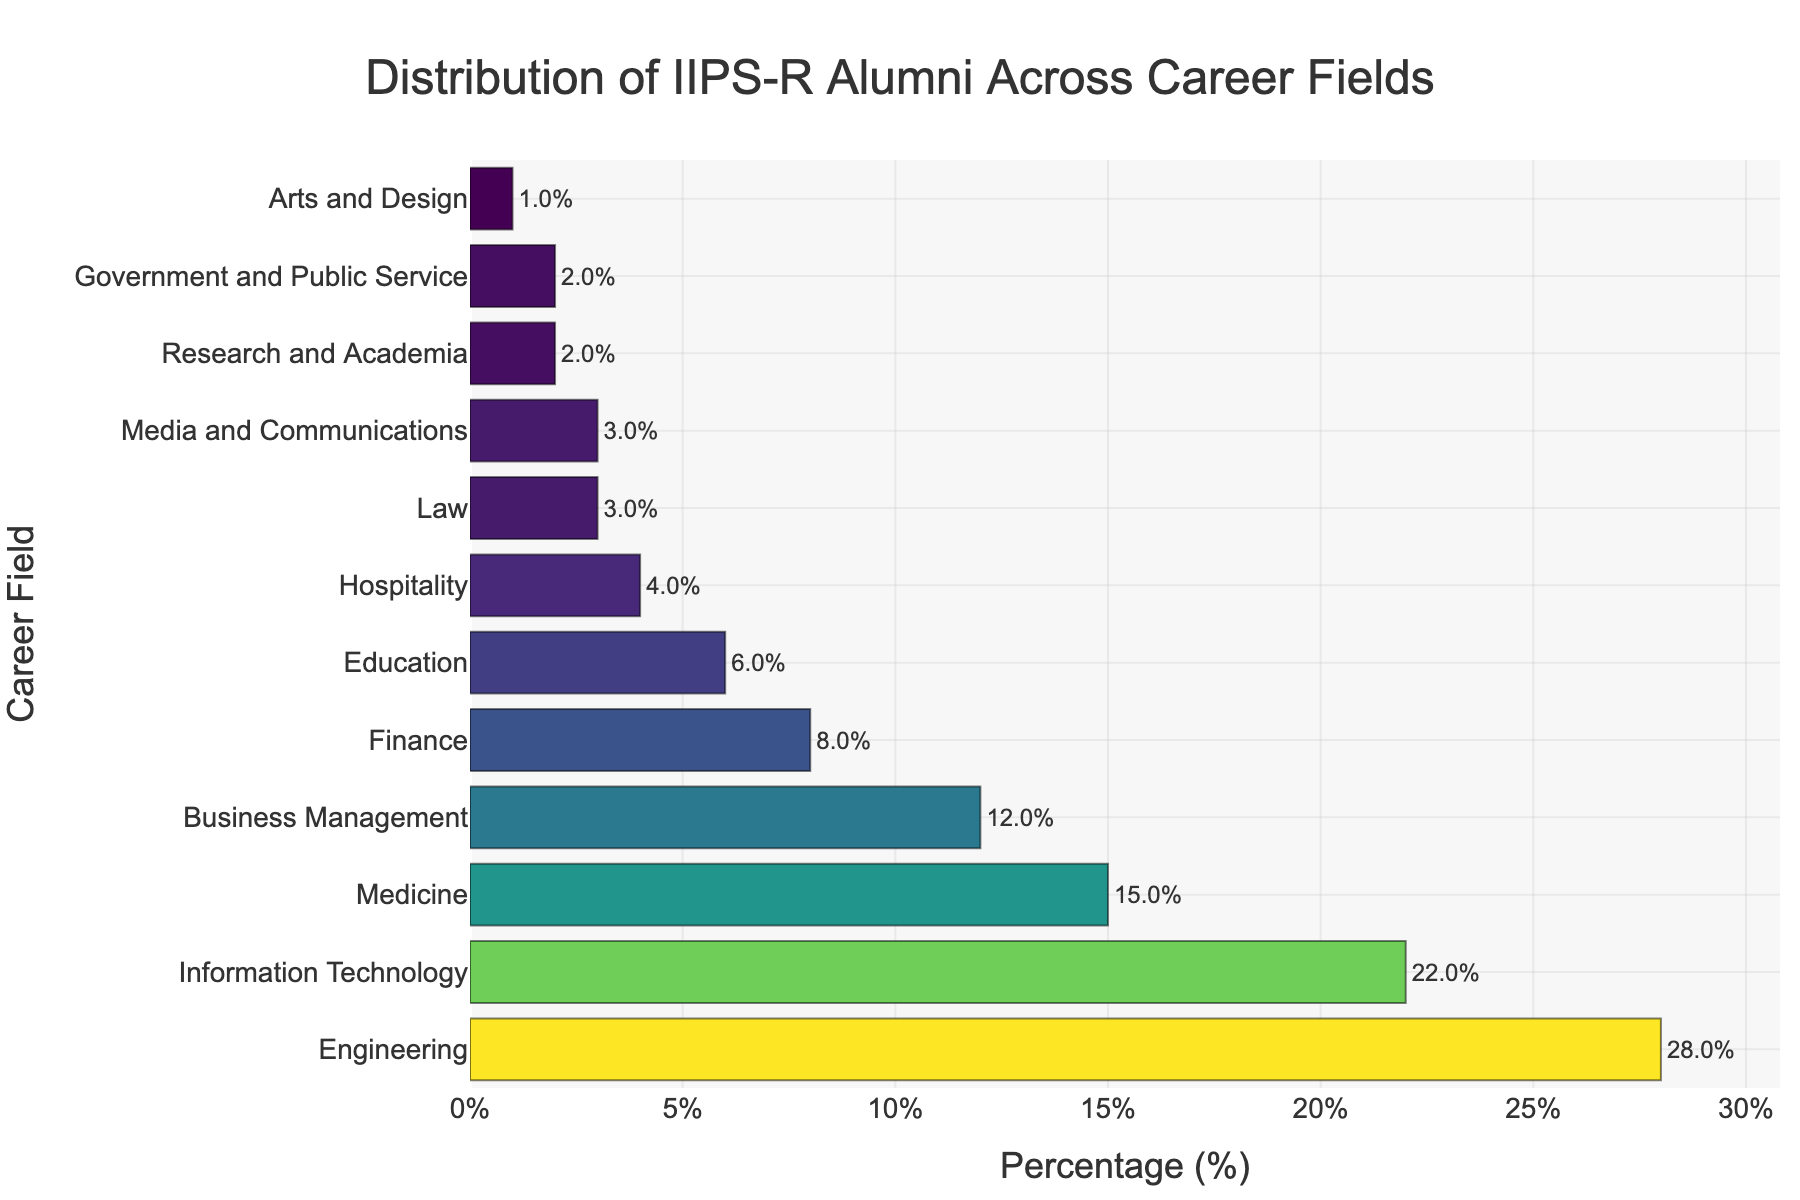Which career field attracts the highest percentage of IIPS-R alumni? The bar with the greatest length represents the career field with the highest percentage. Engineering has the largest bar.
Answer: Engineering Compare the percentage of alumni in Engineering to those in Information Technology. The length of the bars indicates the percentage of alumni. Engineering has 28% while Information Technology has 22%. Subtract to find the difference.
Answer: 6% What is the combined percentage of alumni in Finance, Hospitality, and Law? Add the percentages of each field: Finance (8%), Hospitality (4%), and Law (3%). The total is 8 + 4 + 3.
Answer: 15% Which career fields attract less than 5% of the alumni? Identify bars with less than 5% length. Hospital (4%), Law (3%), Media and Communications (3%), Research and Academia (2%), Government and Public Service (2%), Arts and Design (1%).
Answer: Hospitality, Law, Media and Communications, Research and Academia, Government and Public Service, Arts and Design Is the percentage of alumni in Research and Academia greater or less than that in Government and Public Service? Compare the lengths of the bars for Research and Academia and Government and Public Service. Both have 2%, but the comparison confirms equality.
Answer: Equal Find the total percentage of alumni in the top three career fields. Add the percentages of the top three: Engineering (28%), Information Technology (22%), Medicine (15%). The total is 28 + 22 + 15.
Answer: 65% How many career fields have more than 10% but less than 20% of alumni? Identify bars within the 10-20% range. Information Technology (22%) and Medicine (15%) satisfy this condition.
Answer: 1 What is the difference in percentages between the field with the most alumni and the field with the fewest alumni? Subtract the percentage of Arts and Design (1%) from Engineering (28%).
Answer: 27% Are there more alumni in Business Management or Medicine? Compare the lengths of the Business Management (12%) and Medicine (15%) bars. Medicine has a longer bar.
Answer: Medicine Is the proportion of alumni in Education equal to the combined proportion of those in Hospitality and Law? Compare the percentage of alumni in Education (6%) to the sum of those in Hospitality (4%) and Law (3%). The combined percentage is 4 + 3 = 7%.
Answer: No 